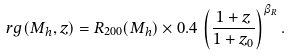Convert formula to latex. <formula><loc_0><loc_0><loc_500><loc_500>\ r g ( M _ { h } , z ) = R _ { 2 0 0 } ( M _ { h } ) \times 0 . 4 \, \left ( \frac { 1 + z } { 1 + z _ { 0 } } \right ) ^ { \beta _ { R } } .</formula> 